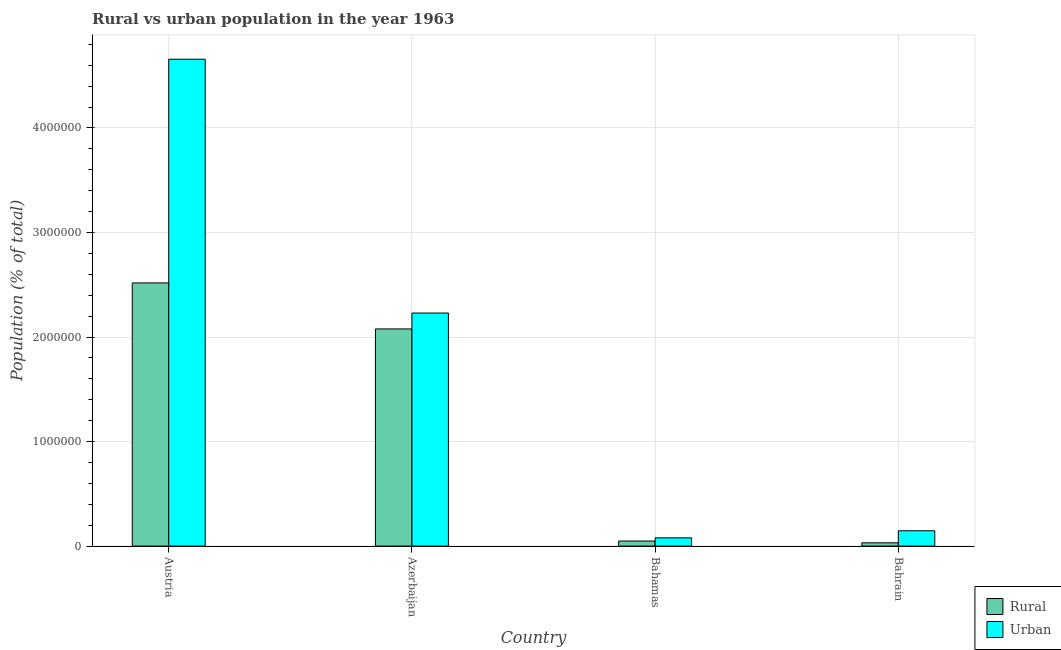How many different coloured bars are there?
Offer a very short reply. 2. How many groups of bars are there?
Your answer should be very brief. 4. Are the number of bars per tick equal to the number of legend labels?
Your answer should be compact. Yes. In how many cases, is the number of bars for a given country not equal to the number of legend labels?
Make the answer very short. 0. What is the urban population density in Azerbaijan?
Make the answer very short. 2.23e+06. Across all countries, what is the maximum rural population density?
Offer a very short reply. 2.52e+06. Across all countries, what is the minimum rural population density?
Ensure brevity in your answer.  3.14e+04. In which country was the urban population density maximum?
Give a very brief answer. Austria. In which country was the urban population density minimum?
Provide a succinct answer. Bahamas. What is the total rural population density in the graph?
Your answer should be compact. 4.68e+06. What is the difference between the urban population density in Austria and that in Bahrain?
Give a very brief answer. 4.51e+06. What is the difference between the urban population density in Bahamas and the rural population density in Azerbaijan?
Provide a succinct answer. -2.00e+06. What is the average rural population density per country?
Ensure brevity in your answer.  1.17e+06. What is the difference between the urban population density and rural population density in Azerbaijan?
Your response must be concise. 1.52e+05. What is the ratio of the rural population density in Austria to that in Bahrain?
Provide a succinct answer. 80.22. Is the rural population density in Austria less than that in Azerbaijan?
Keep it short and to the point. No. Is the difference between the urban population density in Austria and Azerbaijan greater than the difference between the rural population density in Austria and Azerbaijan?
Provide a succinct answer. Yes. What is the difference between the highest and the second highest urban population density?
Ensure brevity in your answer.  2.43e+06. What is the difference between the highest and the lowest urban population density?
Offer a terse response. 4.58e+06. In how many countries, is the rural population density greater than the average rural population density taken over all countries?
Provide a short and direct response. 2. Is the sum of the urban population density in Azerbaijan and Bahrain greater than the maximum rural population density across all countries?
Your response must be concise. No. What does the 1st bar from the left in Austria represents?
Provide a short and direct response. Rural. What does the 2nd bar from the right in Austria represents?
Offer a terse response. Rural. Are all the bars in the graph horizontal?
Give a very brief answer. No. Does the graph contain any zero values?
Provide a short and direct response. No. How are the legend labels stacked?
Ensure brevity in your answer.  Vertical. What is the title of the graph?
Provide a succinct answer. Rural vs urban population in the year 1963. What is the label or title of the Y-axis?
Provide a succinct answer. Population (% of total). What is the Population (% of total) of Rural in Austria?
Make the answer very short. 2.52e+06. What is the Population (% of total) of Urban in Austria?
Your response must be concise. 4.66e+06. What is the Population (% of total) in Rural in Azerbaijan?
Make the answer very short. 2.08e+06. What is the Population (% of total) in Urban in Azerbaijan?
Provide a short and direct response. 2.23e+06. What is the Population (% of total) in Rural in Bahamas?
Your answer should be compact. 4.85e+04. What is the Population (% of total) of Urban in Bahamas?
Provide a short and direct response. 7.89e+04. What is the Population (% of total) in Rural in Bahrain?
Offer a very short reply. 3.14e+04. What is the Population (% of total) of Urban in Bahrain?
Your response must be concise. 1.47e+05. Across all countries, what is the maximum Population (% of total) in Rural?
Provide a succinct answer. 2.52e+06. Across all countries, what is the maximum Population (% of total) of Urban?
Offer a very short reply. 4.66e+06. Across all countries, what is the minimum Population (% of total) in Rural?
Provide a short and direct response. 3.14e+04. Across all countries, what is the minimum Population (% of total) in Urban?
Your answer should be very brief. 7.89e+04. What is the total Population (% of total) of Rural in the graph?
Your answer should be very brief. 4.68e+06. What is the total Population (% of total) in Urban in the graph?
Provide a short and direct response. 7.11e+06. What is the difference between the Population (% of total) of Rural in Austria and that in Azerbaijan?
Keep it short and to the point. 4.40e+05. What is the difference between the Population (% of total) in Urban in Austria and that in Azerbaijan?
Make the answer very short. 2.43e+06. What is the difference between the Population (% of total) in Rural in Austria and that in Bahamas?
Your response must be concise. 2.47e+06. What is the difference between the Population (% of total) in Urban in Austria and that in Bahamas?
Provide a short and direct response. 4.58e+06. What is the difference between the Population (% of total) of Rural in Austria and that in Bahrain?
Make the answer very short. 2.49e+06. What is the difference between the Population (% of total) of Urban in Austria and that in Bahrain?
Keep it short and to the point. 4.51e+06. What is the difference between the Population (% of total) in Rural in Azerbaijan and that in Bahamas?
Offer a terse response. 2.03e+06. What is the difference between the Population (% of total) of Urban in Azerbaijan and that in Bahamas?
Your answer should be compact. 2.15e+06. What is the difference between the Population (% of total) of Rural in Azerbaijan and that in Bahrain?
Make the answer very short. 2.05e+06. What is the difference between the Population (% of total) of Urban in Azerbaijan and that in Bahrain?
Offer a very short reply. 2.08e+06. What is the difference between the Population (% of total) in Rural in Bahamas and that in Bahrain?
Offer a very short reply. 1.71e+04. What is the difference between the Population (% of total) in Urban in Bahamas and that in Bahrain?
Make the answer very short. -6.78e+04. What is the difference between the Population (% of total) of Rural in Austria and the Population (% of total) of Urban in Azerbaijan?
Your response must be concise. 2.88e+05. What is the difference between the Population (% of total) in Rural in Austria and the Population (% of total) in Urban in Bahamas?
Provide a succinct answer. 2.44e+06. What is the difference between the Population (% of total) in Rural in Austria and the Population (% of total) in Urban in Bahrain?
Offer a terse response. 2.37e+06. What is the difference between the Population (% of total) in Rural in Azerbaijan and the Population (% of total) in Urban in Bahamas?
Ensure brevity in your answer.  2.00e+06. What is the difference between the Population (% of total) in Rural in Azerbaijan and the Population (% of total) in Urban in Bahrain?
Provide a short and direct response. 1.93e+06. What is the difference between the Population (% of total) in Rural in Bahamas and the Population (% of total) in Urban in Bahrain?
Make the answer very short. -9.82e+04. What is the average Population (% of total) of Rural per country?
Offer a very short reply. 1.17e+06. What is the average Population (% of total) in Urban per country?
Your answer should be very brief. 1.78e+06. What is the difference between the Population (% of total) in Rural and Population (% of total) in Urban in Austria?
Give a very brief answer. -2.14e+06. What is the difference between the Population (% of total) of Rural and Population (% of total) of Urban in Azerbaijan?
Offer a very short reply. -1.52e+05. What is the difference between the Population (% of total) in Rural and Population (% of total) in Urban in Bahamas?
Offer a terse response. -3.04e+04. What is the difference between the Population (% of total) of Rural and Population (% of total) of Urban in Bahrain?
Offer a very short reply. -1.15e+05. What is the ratio of the Population (% of total) in Rural in Austria to that in Azerbaijan?
Your response must be concise. 1.21. What is the ratio of the Population (% of total) in Urban in Austria to that in Azerbaijan?
Offer a terse response. 2.09. What is the ratio of the Population (% of total) in Rural in Austria to that in Bahamas?
Your answer should be very brief. 51.93. What is the ratio of the Population (% of total) in Urban in Austria to that in Bahamas?
Keep it short and to the point. 59.07. What is the ratio of the Population (% of total) of Rural in Austria to that in Bahrain?
Your answer should be very brief. 80.22. What is the ratio of the Population (% of total) in Urban in Austria to that in Bahrain?
Provide a short and direct response. 31.76. What is the ratio of the Population (% of total) in Rural in Azerbaijan to that in Bahamas?
Your response must be concise. 42.86. What is the ratio of the Population (% of total) in Urban in Azerbaijan to that in Bahamas?
Provide a succinct answer. 28.28. What is the ratio of the Population (% of total) of Rural in Azerbaijan to that in Bahrain?
Your answer should be compact. 66.2. What is the ratio of the Population (% of total) in Urban in Azerbaijan to that in Bahrain?
Offer a very short reply. 15.2. What is the ratio of the Population (% of total) in Rural in Bahamas to that in Bahrain?
Offer a terse response. 1.54. What is the ratio of the Population (% of total) of Urban in Bahamas to that in Bahrain?
Your response must be concise. 0.54. What is the difference between the highest and the second highest Population (% of total) of Rural?
Make the answer very short. 4.40e+05. What is the difference between the highest and the second highest Population (% of total) in Urban?
Make the answer very short. 2.43e+06. What is the difference between the highest and the lowest Population (% of total) in Rural?
Make the answer very short. 2.49e+06. What is the difference between the highest and the lowest Population (% of total) in Urban?
Provide a succinct answer. 4.58e+06. 